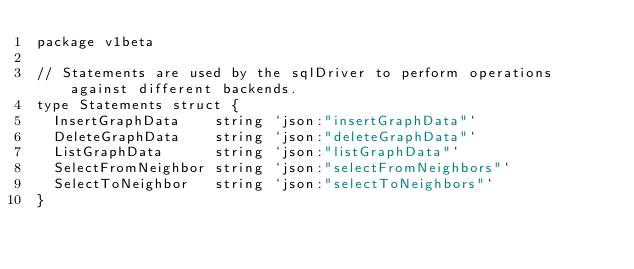<code> <loc_0><loc_0><loc_500><loc_500><_Go_>package v1beta

// Statements are used by the sqlDriver to perform operations against different backends.
type Statements struct {
	InsertGraphData    string `json:"insertGraphData"`
	DeleteGraphData    string `json:"deleteGraphData"`
	ListGraphData      string `json:"listGraphData"`
	SelectFromNeighbor string `json:"selectFromNeighbors"`
	SelectToNeighbor   string `json:"selectToNeighbors"`
}
</code> 